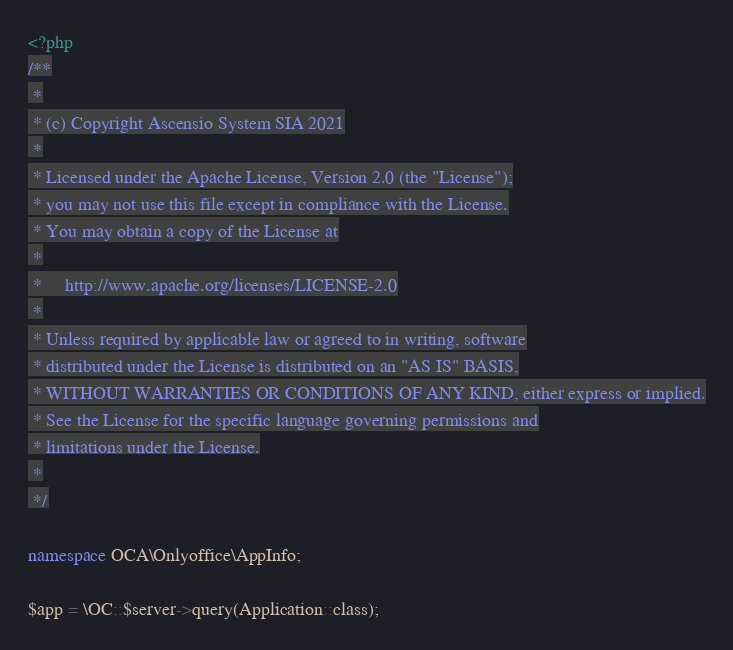Convert code to text. <code><loc_0><loc_0><loc_500><loc_500><_PHP_><?php
/**
 *
 * (c) Copyright Ascensio System SIA 2021
 *
 * Licensed under the Apache License, Version 2.0 (the "License");
 * you may not use this file except in compliance with the License.
 * You may obtain a copy of the License at
 *
 *     http://www.apache.org/licenses/LICENSE-2.0
 *
 * Unless required by applicable law or agreed to in writing, software
 * distributed under the License is distributed on an "AS IS" BASIS,
 * WITHOUT WARRANTIES OR CONDITIONS OF ANY KIND, either express or implied.
 * See the License for the specific language governing permissions and
 * limitations under the License.
 *
 */

namespace OCA\Onlyoffice\AppInfo;

$app = \OC::$server->query(Application::class);
</code> 